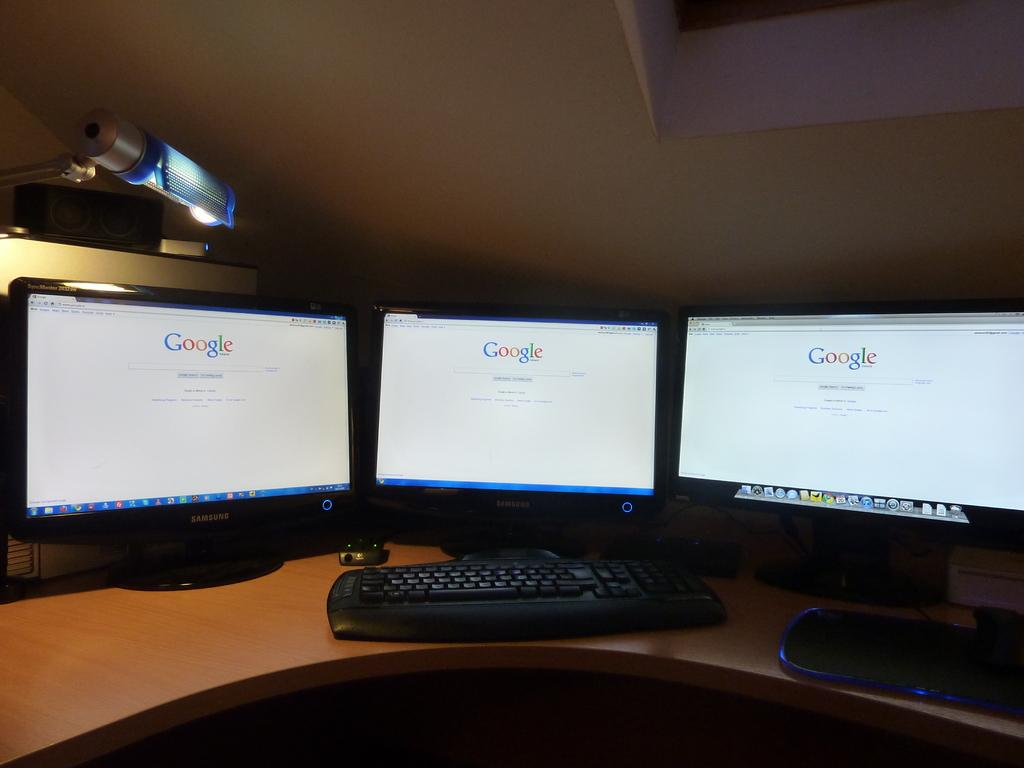<image>
Give a short and clear explanation of the subsequent image. Three computers screen are all turned onto Google. 